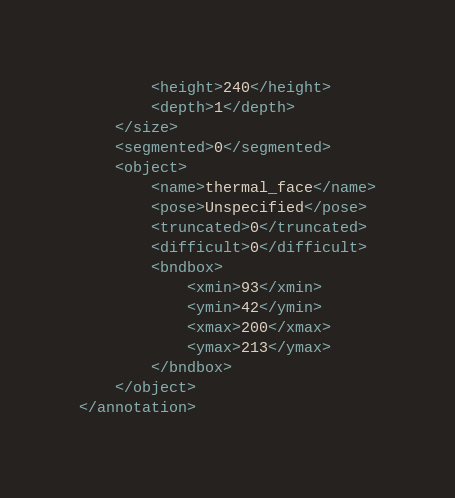<code> <loc_0><loc_0><loc_500><loc_500><_XML_>		<height>240</height>
		<depth>1</depth>
	</size>
	<segmented>0</segmented>
	<object>
		<name>thermal_face</name>
		<pose>Unspecified</pose>
		<truncated>0</truncated>
		<difficult>0</difficult>
		<bndbox>
			<xmin>93</xmin>
			<ymin>42</ymin>
			<xmax>200</xmax>
			<ymax>213</ymax>
		</bndbox>
	</object>
</annotation>
</code> 